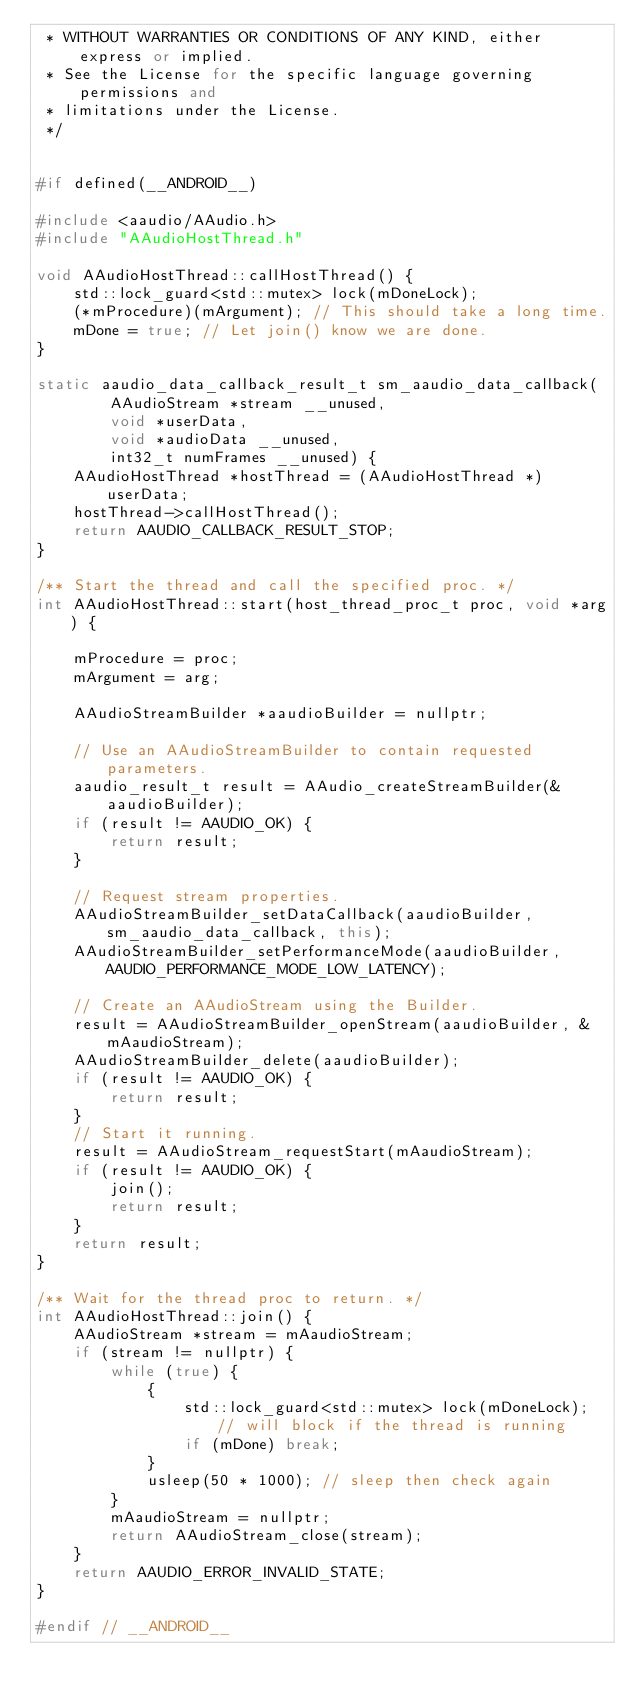<code> <loc_0><loc_0><loc_500><loc_500><_C++_> * WITHOUT WARRANTIES OR CONDITIONS OF ANY KIND, either express or implied.
 * See the License for the specific language governing permissions and
 * limitations under the License.
 */


#if defined(__ANDROID__)

#include <aaudio/AAudio.h>
#include "AAudioHostThread.h"

void AAudioHostThread::callHostThread() {
    std::lock_guard<std::mutex> lock(mDoneLock);
    (*mProcedure)(mArgument); // This should take a long time.
    mDone = true; // Let join() know we are done.
}

static aaudio_data_callback_result_t sm_aaudio_data_callback(
        AAudioStream *stream __unused,
        void *userData,
        void *audioData __unused,
        int32_t numFrames __unused) {
    AAudioHostThread *hostThread = (AAudioHostThread *) userData;
    hostThread->callHostThread();
    return AAUDIO_CALLBACK_RESULT_STOP;
}

/** Start the thread and call the specified proc. */
int AAudioHostThread::start(host_thread_proc_t proc, void *arg) {

    mProcedure = proc;
    mArgument = arg;

    AAudioStreamBuilder *aaudioBuilder = nullptr;

    // Use an AAudioStreamBuilder to contain requested parameters.
    aaudio_result_t result = AAudio_createStreamBuilder(&aaudioBuilder);
    if (result != AAUDIO_OK) {
        return result;
    }

    // Request stream properties.
    AAudioStreamBuilder_setDataCallback(aaudioBuilder, sm_aaudio_data_callback, this);
    AAudioStreamBuilder_setPerformanceMode(aaudioBuilder, AAUDIO_PERFORMANCE_MODE_LOW_LATENCY);

    // Create an AAudioStream using the Builder.
    result = AAudioStreamBuilder_openStream(aaudioBuilder, &mAaudioStream);
    AAudioStreamBuilder_delete(aaudioBuilder);
    if (result != AAUDIO_OK) {
        return result;
    }
    // Start it running.
    result = AAudioStream_requestStart(mAaudioStream);
    if (result != AAUDIO_OK) {
        join();
        return result;
    }
    return result;
}

/** Wait for the thread proc to return. */
int AAudioHostThread::join() {
    AAudioStream *stream = mAaudioStream;
    if (stream != nullptr) {
        while (true) {
            {
                std::lock_guard<std::mutex> lock(mDoneLock); // will block if the thread is running
                if (mDone) break;
            }
            usleep(50 * 1000); // sleep then check again
        }
        mAaudioStream = nullptr;
        return AAudioStream_close(stream);
    }
    return AAUDIO_ERROR_INVALID_STATE;
}

#endif // __ANDROID__
</code> 